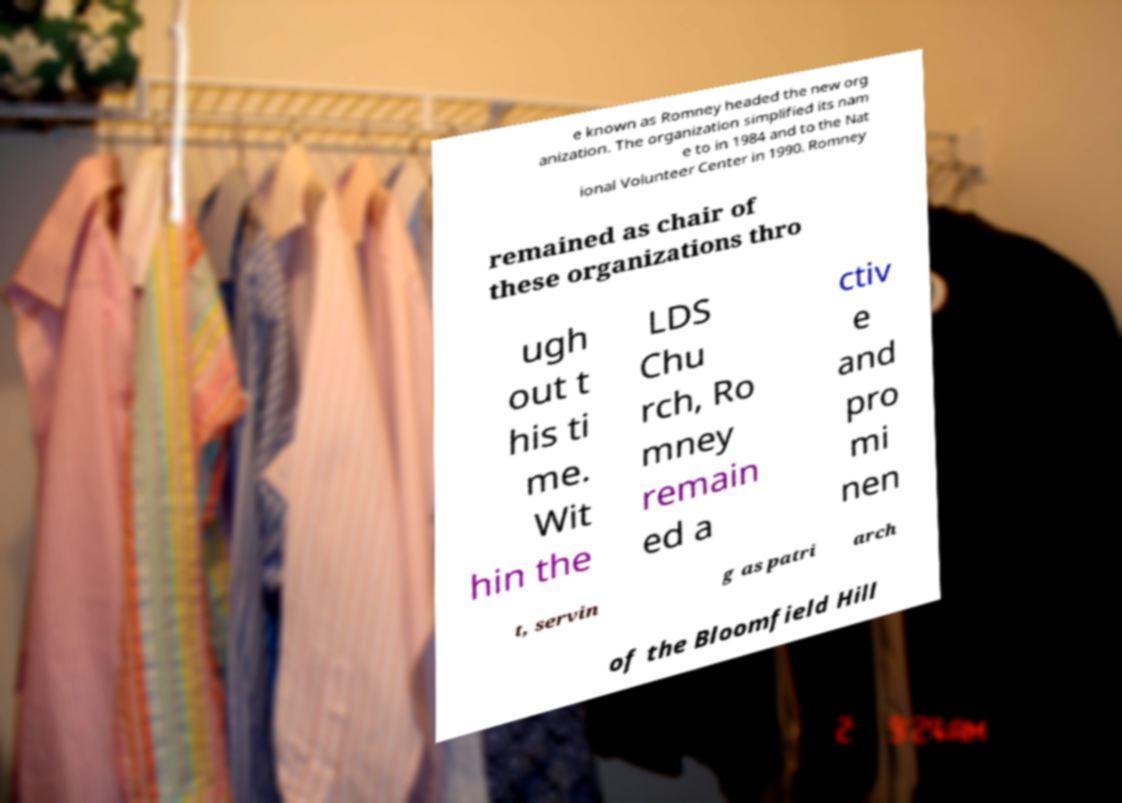Please identify and transcribe the text found in this image. e known as Romney headed the new org anization. The organization simplified its nam e to in 1984 and to the Nat ional Volunteer Center in 1990. Romney remained as chair of these organizations thro ugh out t his ti me. Wit hin the LDS Chu rch, Ro mney remain ed a ctiv e and pro mi nen t, servin g as patri arch of the Bloomfield Hill 